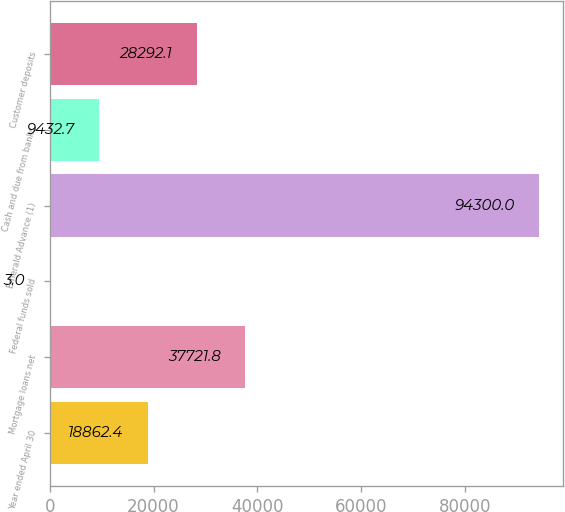Convert chart. <chart><loc_0><loc_0><loc_500><loc_500><bar_chart><fcel>Year ended April 30<fcel>Mortgage loans net<fcel>Federal funds sold<fcel>Emerald Advance (1)<fcel>Cash and due from banks<fcel>Customer deposits<nl><fcel>18862.4<fcel>37721.8<fcel>3<fcel>94300<fcel>9432.7<fcel>28292.1<nl></chart> 